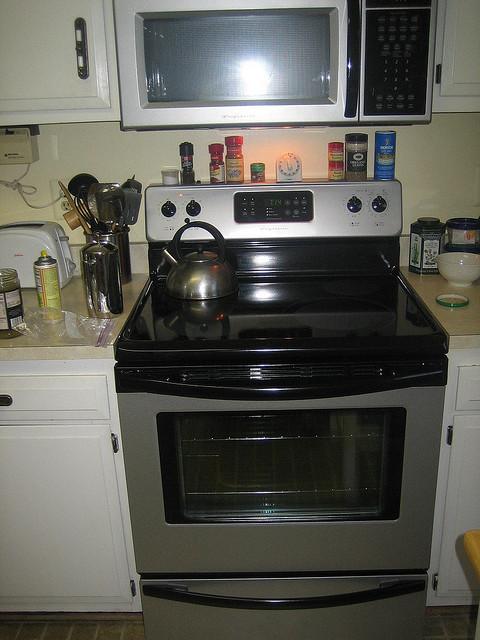Is the oven on?
Answer briefly. No. Is this a gas stove?
Be succinct. No. How many people are reflected in the microwave window?
Write a very short answer. 0. Is this an electric oven?
Short answer required. Yes. Where is the tea kettle?
Write a very short answer. On stove. Is this a gas oven?
Keep it brief. No. What typical beverage can be made by the instrument on the stove top?
Answer briefly. Tea. Where is the kettle?
Be succinct. Stove. What kind of food is in the jar on the counter?
Short answer required. Spices. Is there anything inside of the stove?
Keep it brief. No. 